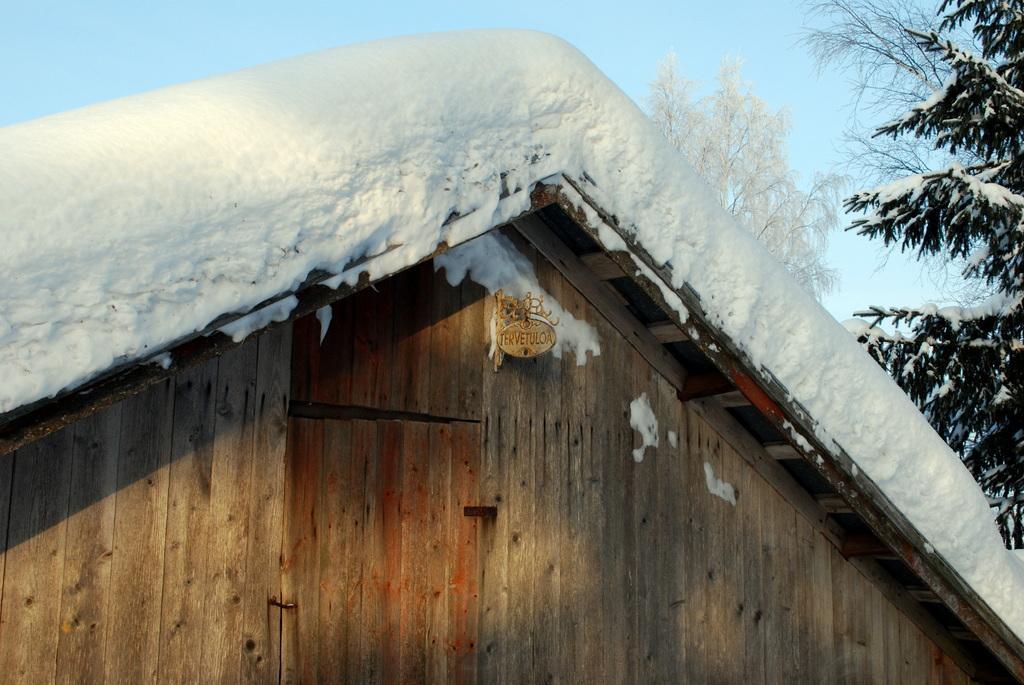In one or two sentences, can you explain what this image depicts? In the center of the image there is a wooden house with snow on its roof top. In the background of the image there is sky and trees. 